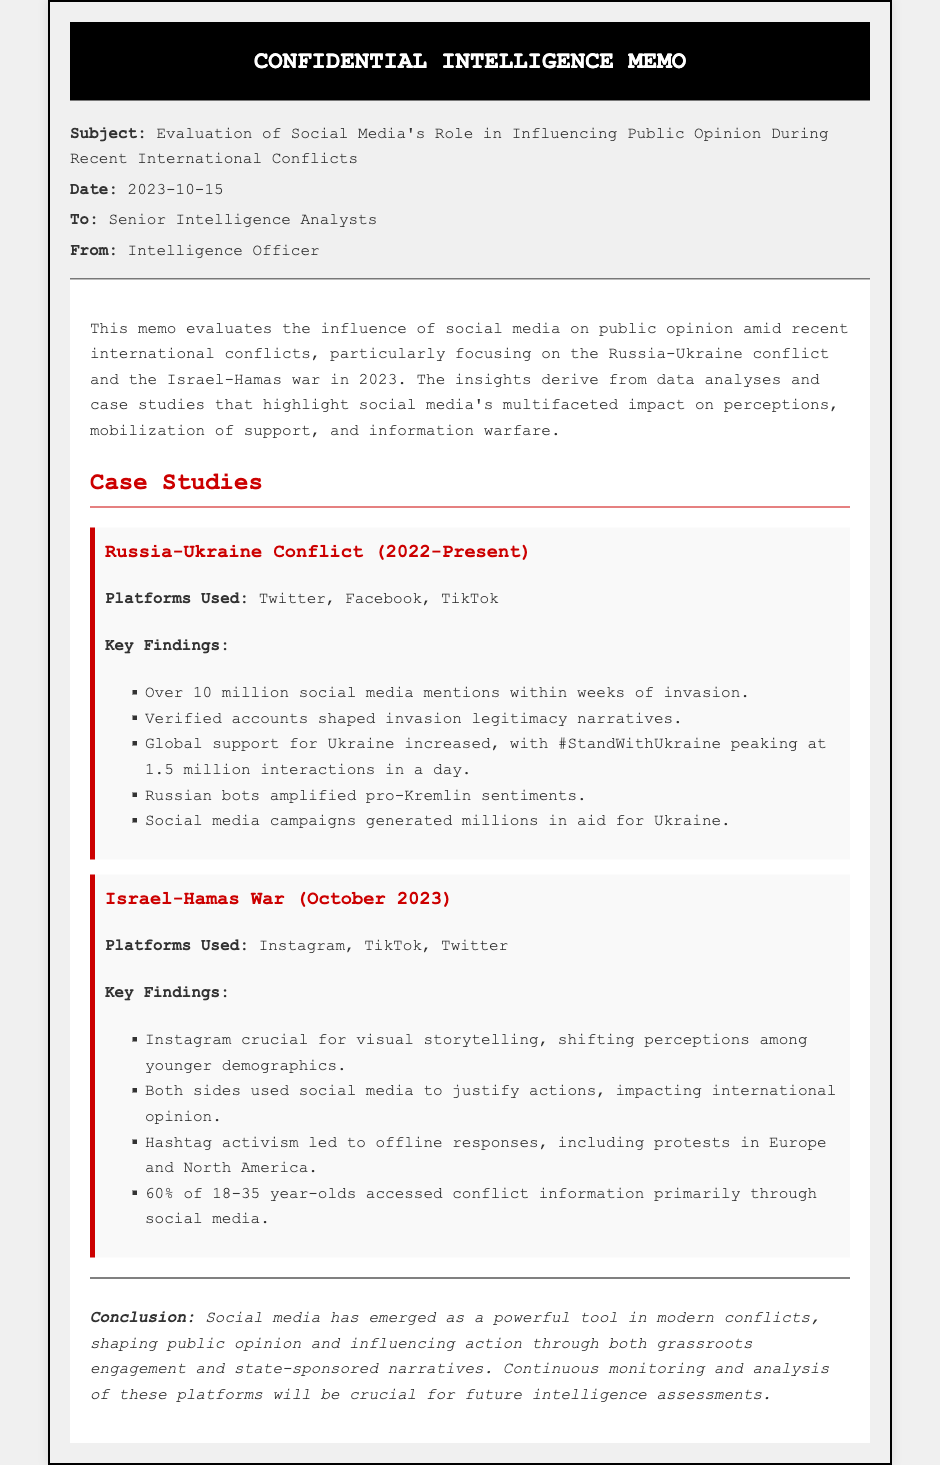what is the subject of the memo? The subject of the memo discusses the influence of social media on public opinion during recent international conflicts.
Answer: Evaluation of Social Media's Role in Influencing Public Opinion During Recent International Conflicts what date was the memo issued? The date listed in the memo is when it was authored.
Answer: 2023-10-15 how many social media mentions were identified in the Russia-Ukraine conflict? The memo notes a specific number indicating social media activity during the conflict.
Answer: Over 10 million which platform was crucial for visual storytelling in the Israel-Hamas War? The memo highlights the primary platform that played an important role in shaping perceptions.
Answer: Instagram what was the peak number of interactions for the hashtag #StandWithUkraine? The memo provides a specific figure for interactions related to a prominent hashtag during the conflict.
Answer: 1.5 million how many percent of young people accessed conflict information primarily through social media during the Israel-Hamas war? A percentage is stated in the memo regarding the demographic trend in information access.
Answer: 60% what is mentioned as a consequence of hashtag activism in the Israel-Hamas conflict? The memo details an outcome related to activism via social media during the conflict.
Answer: Offline responses, including protests in Europe and North America what is the conclusion about social media's role in modern conflicts? The conclusion summarizes the key findings about the impact of social media on public opinion and actions during conflicts.
Answer: A powerful tool in modern conflicts 